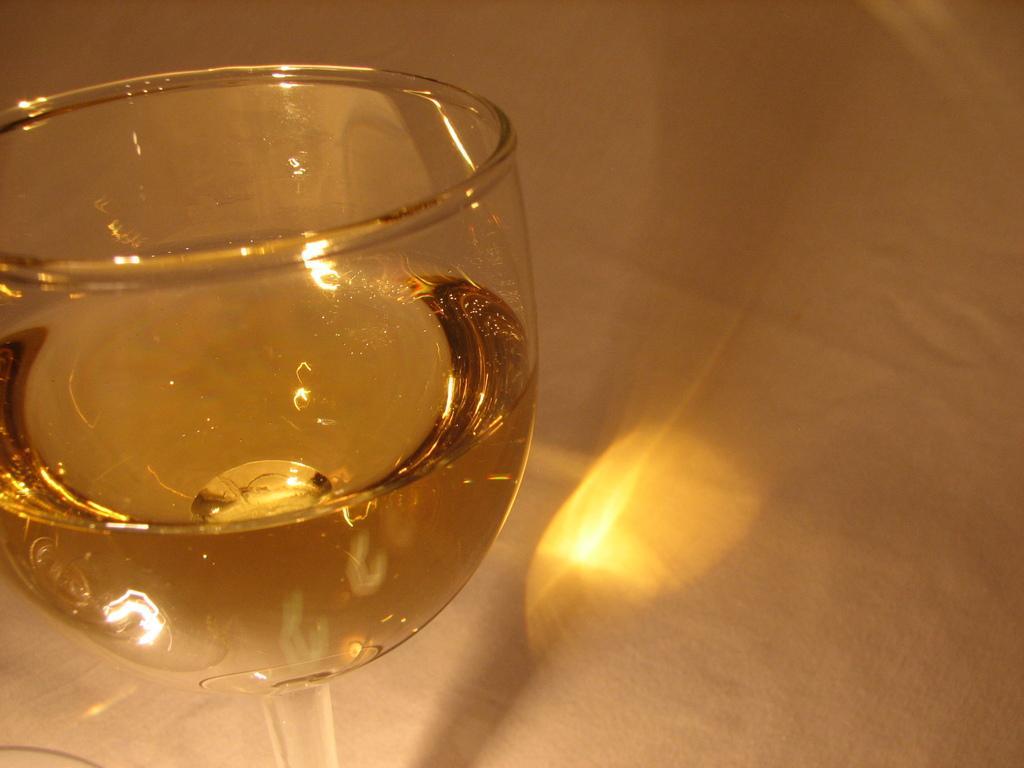Can you describe this image briefly? In this picture we can see a glass with drink in it and this glass is placed on a platform. 